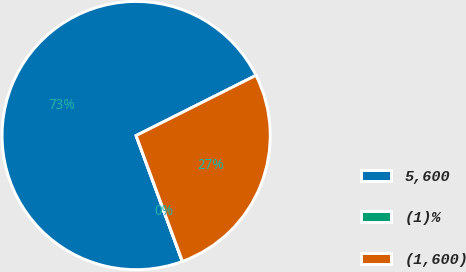Convert chart to OTSL. <chart><loc_0><loc_0><loc_500><loc_500><pie_chart><fcel>5,600<fcel>(1)%<fcel>(1,600)<nl><fcel>73.19%<fcel>0.02%<fcel>26.8%<nl></chart> 